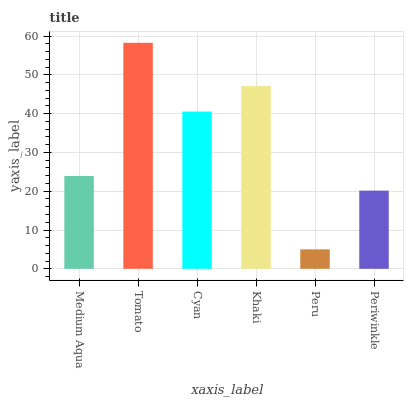Is Peru the minimum?
Answer yes or no. Yes. Is Tomato the maximum?
Answer yes or no. Yes. Is Cyan the minimum?
Answer yes or no. No. Is Cyan the maximum?
Answer yes or no. No. Is Tomato greater than Cyan?
Answer yes or no. Yes. Is Cyan less than Tomato?
Answer yes or no. Yes. Is Cyan greater than Tomato?
Answer yes or no. No. Is Tomato less than Cyan?
Answer yes or no. No. Is Cyan the high median?
Answer yes or no. Yes. Is Medium Aqua the low median?
Answer yes or no. Yes. Is Peru the high median?
Answer yes or no. No. Is Tomato the low median?
Answer yes or no. No. 